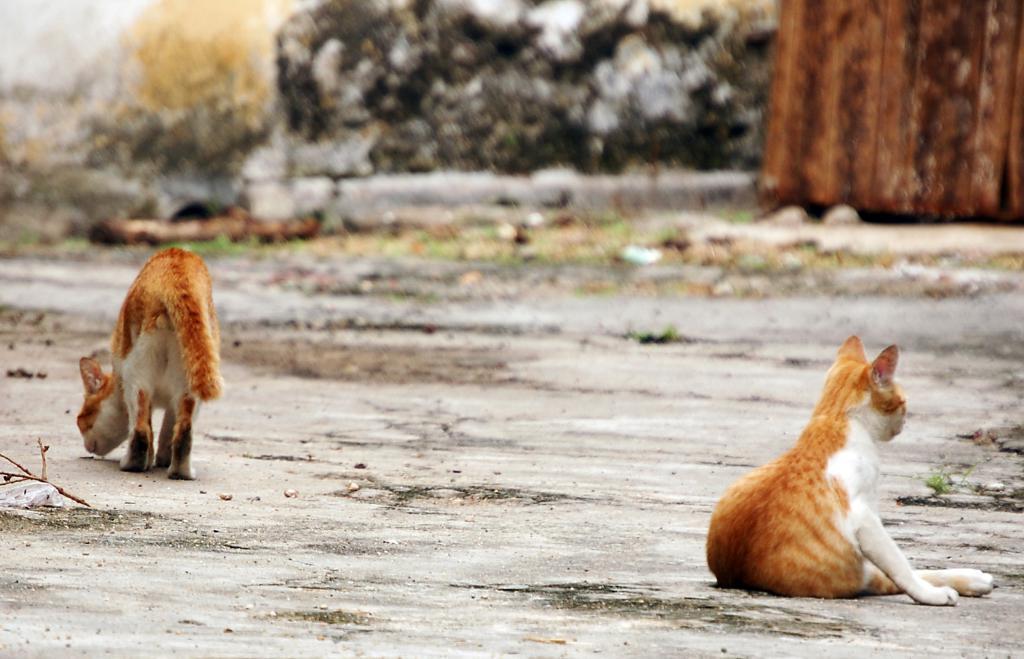In one or two sentences, can you explain what this image depicts? In this image we can see cats on the ground. In the background we can see wall. 